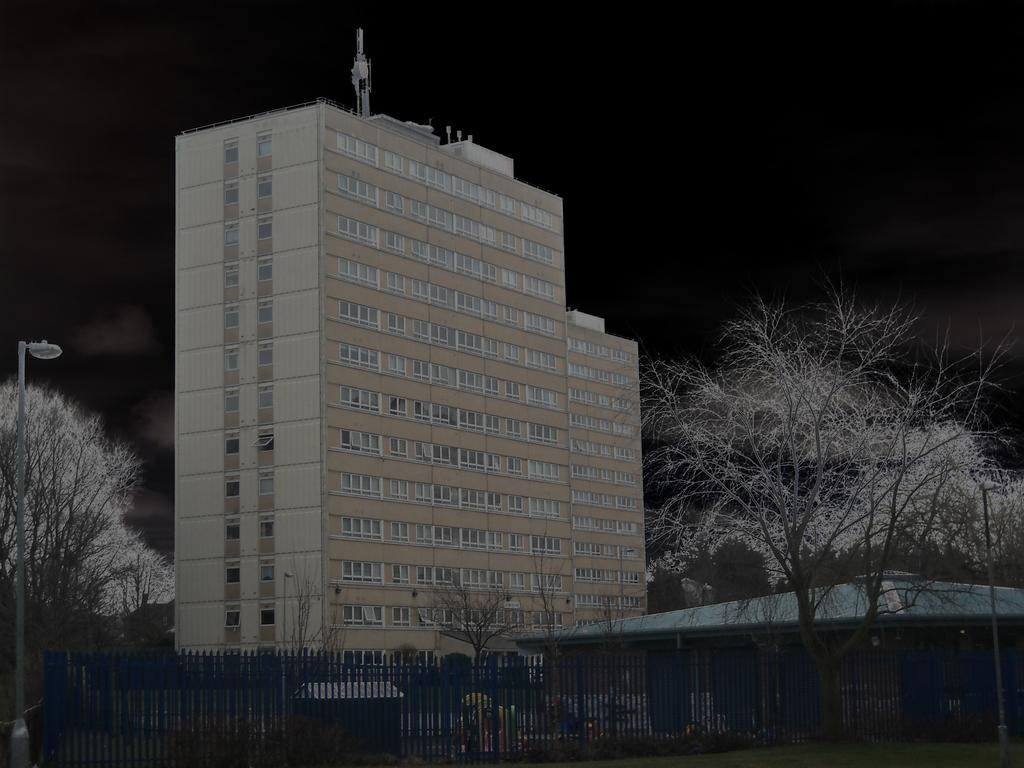What type of structure is visible in the image? There is a building in the image. What other natural elements can be seen in the image? There are trees in the image. What type of barrier is present in the image? There is a metal fence in the image. What type of lighting is present in the image? There is a pole light in the image. How would you describe the overall lighting in the image? The background of the image is dark. How many ladybugs are crawling on the building in the image? There are no ladybugs present in the image. What type of wire is used to connect the pole light to the building? There is no wire connecting the pole light to the building in the image. 